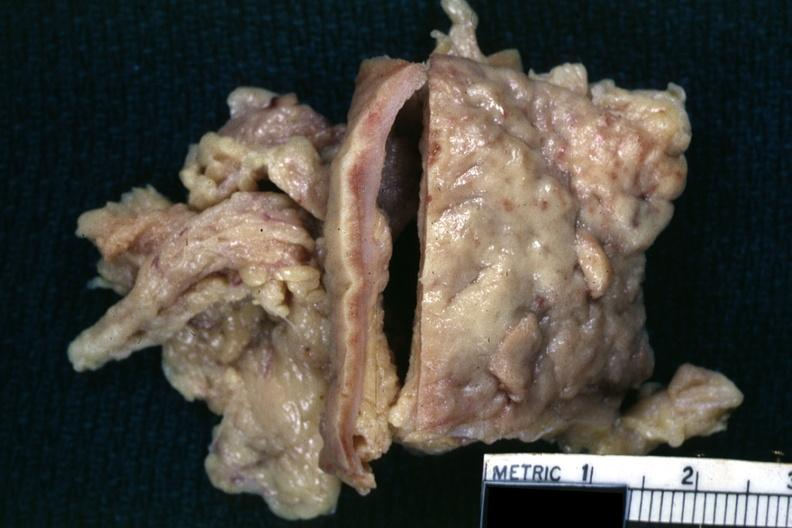s omentum present?
Answer the question using a single word or phrase. Yes 